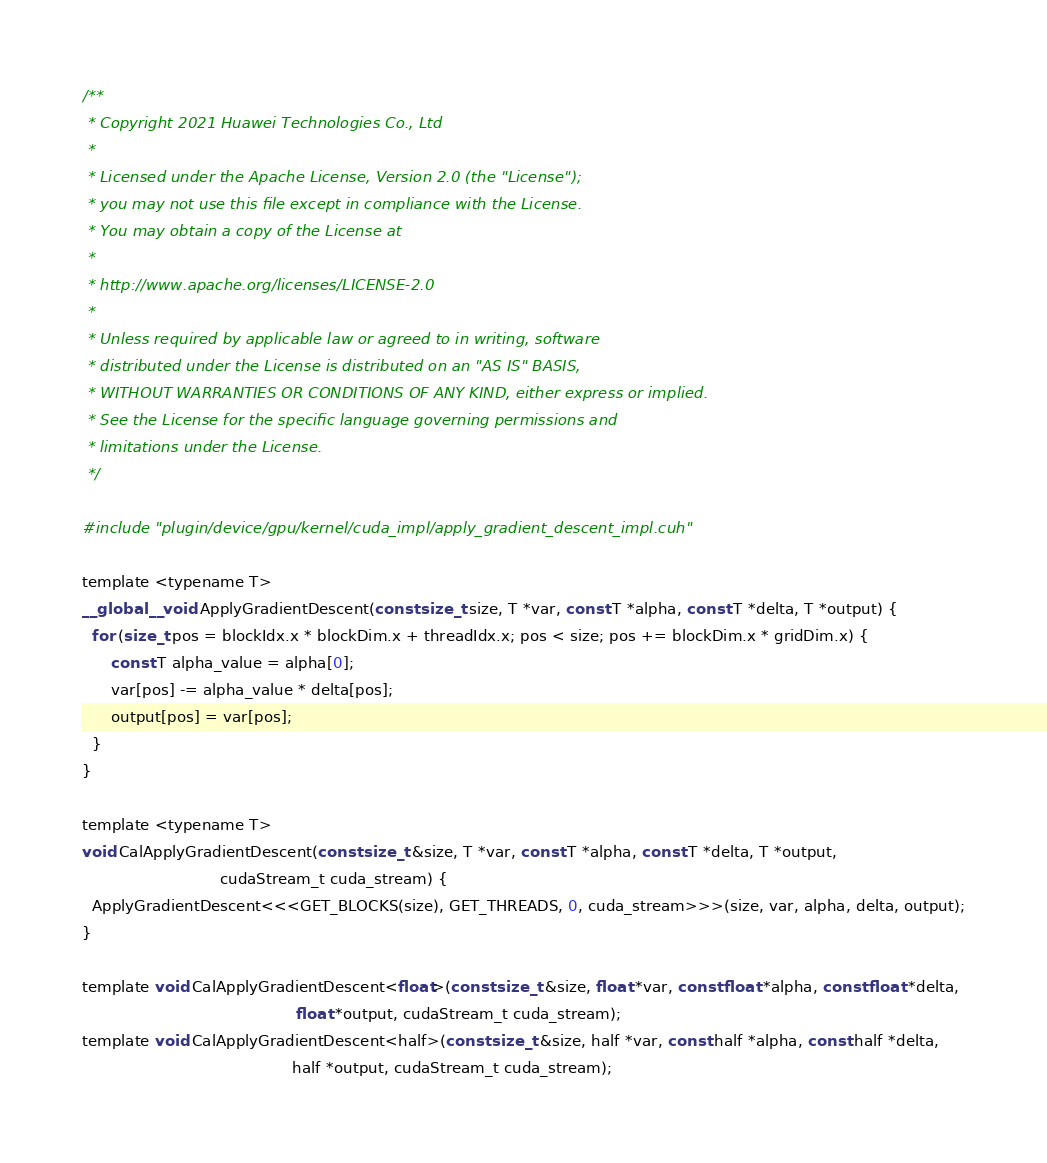Convert code to text. <code><loc_0><loc_0><loc_500><loc_500><_Cuda_>/**
 * Copyright 2021 Huawei Technologies Co., Ltd
 *
 * Licensed under the Apache License, Version 2.0 (the "License");
 * you may not use this file except in compliance with the License.
 * You may obtain a copy of the License at
 *
 * http://www.apache.org/licenses/LICENSE-2.0
 *
 * Unless required by applicable law or agreed to in writing, software
 * distributed under the License is distributed on an "AS IS" BASIS,
 * WITHOUT WARRANTIES OR CONDITIONS OF ANY KIND, either express or implied.
 * See the License for the specific language governing permissions and
 * limitations under the License.
 */

#include "plugin/device/gpu/kernel/cuda_impl/apply_gradient_descent_impl.cuh"

template <typename T>
__global__ void ApplyGradientDescent(const size_t size, T *var, const T *alpha, const T *delta, T *output) {
  for (size_t pos = blockIdx.x * blockDim.x + threadIdx.x; pos < size; pos += blockDim.x * gridDim.x) {
      const T alpha_value = alpha[0];
      var[pos] -= alpha_value * delta[pos];
      output[pos] = var[pos];
  }
}

template <typename T>
void CalApplyGradientDescent(const size_t &size, T *var, const T *alpha, const T *delta, T *output,
                             cudaStream_t cuda_stream) {
  ApplyGradientDescent<<<GET_BLOCKS(size), GET_THREADS, 0, cuda_stream>>>(size, var, alpha, delta, output);
}

template void CalApplyGradientDescent<float>(const size_t &size, float *var, const float *alpha, const float *delta,
                                             float *output, cudaStream_t cuda_stream);
template void CalApplyGradientDescent<half>(const size_t &size, half *var, const half *alpha, const half *delta,
                                            half *output, cudaStream_t cuda_stream);
</code> 